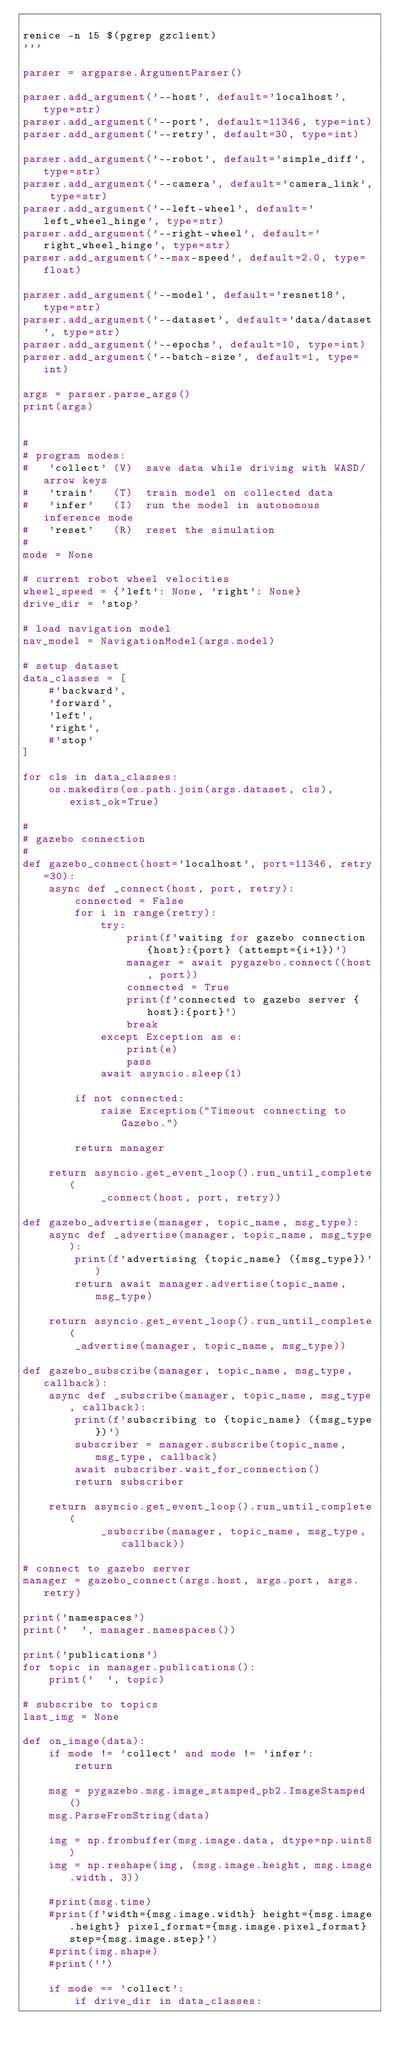<code> <loc_0><loc_0><loc_500><loc_500><_Python_>
renice -n 15 $(pgrep gzclient)
'''

parser = argparse.ArgumentParser()

parser.add_argument('--host', default='localhost', type=str)
parser.add_argument('--port', default=11346, type=int)
parser.add_argument('--retry', default=30, type=int)

parser.add_argument('--robot', default='simple_diff', type=str)
parser.add_argument('--camera', default='camera_link', type=str)
parser.add_argument('--left-wheel', default='left_wheel_hinge', type=str)
parser.add_argument('--right-wheel', default='right_wheel_hinge', type=str)
parser.add_argument('--max-speed', default=2.0, type=float)

parser.add_argument('--model', default='resnet18', type=str)
parser.add_argument('--dataset', default='data/dataset', type=str)
parser.add_argument('--epochs', default=10, type=int)
parser.add_argument('--batch-size', default=1, type=int)

args = parser.parse_args()
print(args)


# 
# program modes:
#   'collect' (V)  save data while driving with WASD/arrow keys
#   'train'   (T)  train model on collected data
#   'infer'   (I)  run the model in autonomous inference mode
#   'reset'   (R)  reset the simulation
#
mode = None

# current robot wheel velocities
wheel_speed = {'left': None, 'right': None}
drive_dir = 'stop'

# load navigation model
nav_model = NavigationModel(args.model)

# setup dataset
data_classes = [
    #'backward',
    'forward',
    'left',
    'right',
    #'stop'
]

for cls in data_classes:
    os.makedirs(os.path.join(args.dataset, cls), exist_ok=True)

#
# gazebo connection
#
def gazebo_connect(host='localhost', port=11346, retry=30):
    async def _connect(host, port, retry):
        connected = False
        for i in range(retry):
            try:
                print(f'waiting for gazebo connection {host}:{port} (attempt={i+1})')
                manager = await pygazebo.connect((host, port))
                connected = True
                print(f'connected to gazebo server {host}:{port}')
                break
            except Exception as e:
                print(e)
                pass
            await asyncio.sleep(1)

        if not connected: 
            raise Exception("Timeout connecting to Gazebo.")
            
        return manager

    return asyncio.get_event_loop().run_until_complete(
            _connect(host, port, retry))

def gazebo_advertise(manager, topic_name, msg_type):
    async def _advertise(manager, topic_name, msg_type):
        print(f'advertising {topic_name} ({msg_type})')
        return await manager.advertise(topic_name, msg_type)
        
    return asyncio.get_event_loop().run_until_complete(
        _advertise(manager, topic_name, msg_type))
        
def gazebo_subscribe(manager, topic_name, msg_type, callback):
    async def _subscribe(manager, topic_name, msg_type, callback):
        print(f'subscribing to {topic_name} ({msg_type})')
        subscriber = manager.subscribe(topic_name, msg_type, callback)
        await subscriber.wait_for_connection()
        return subscriber
    
    return asyncio.get_event_loop().run_until_complete(
            _subscribe(manager, topic_name, msg_type, callback))

# connect to gazebo server    
manager = gazebo_connect(args.host, args.port, args.retry)

print('namespaces')
print('  ', manager.namespaces())

print('publications')
for topic in manager.publications():
    print('  ', topic)

# subscribe to topics
last_img = None

def on_image(data):
    if mode != 'collect' and mode != 'infer':
        return
        
    msg = pygazebo.msg.image_stamped_pb2.ImageStamped()
    msg.ParseFromString(data)
    
    img = np.frombuffer(msg.image.data, dtype=np.uint8)
    img = np.reshape(img, (msg.image.height, msg.image.width, 3))
    
    #print(msg.time)
    #print(f'width={msg.image.width} height={msg.image.height} pixel_format={msg.image.pixel_format} step={msg.image.step}')
    #print(img.shape)
    #print('')
    
    if mode == 'collect':
        if drive_dir in data_classes:</code> 